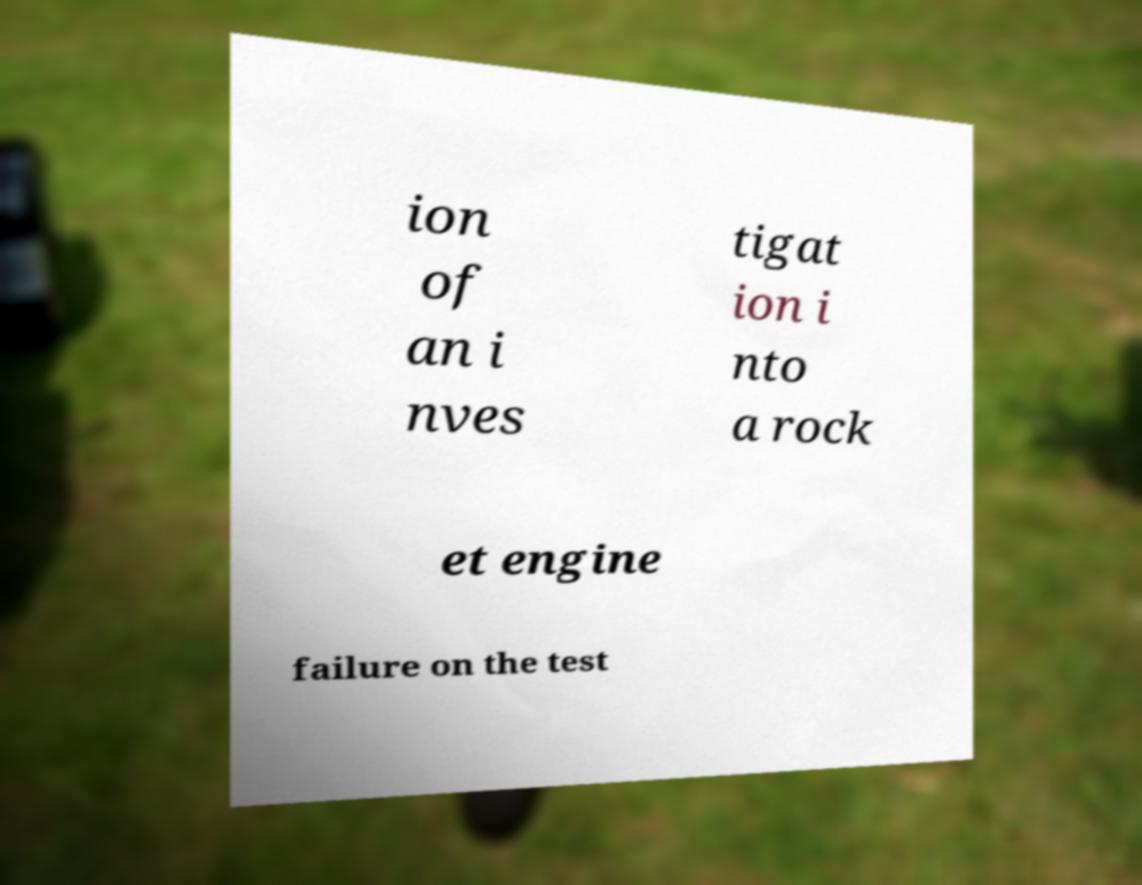Can you read and provide the text displayed in the image?This photo seems to have some interesting text. Can you extract and type it out for me? ion of an i nves tigat ion i nto a rock et engine failure on the test 